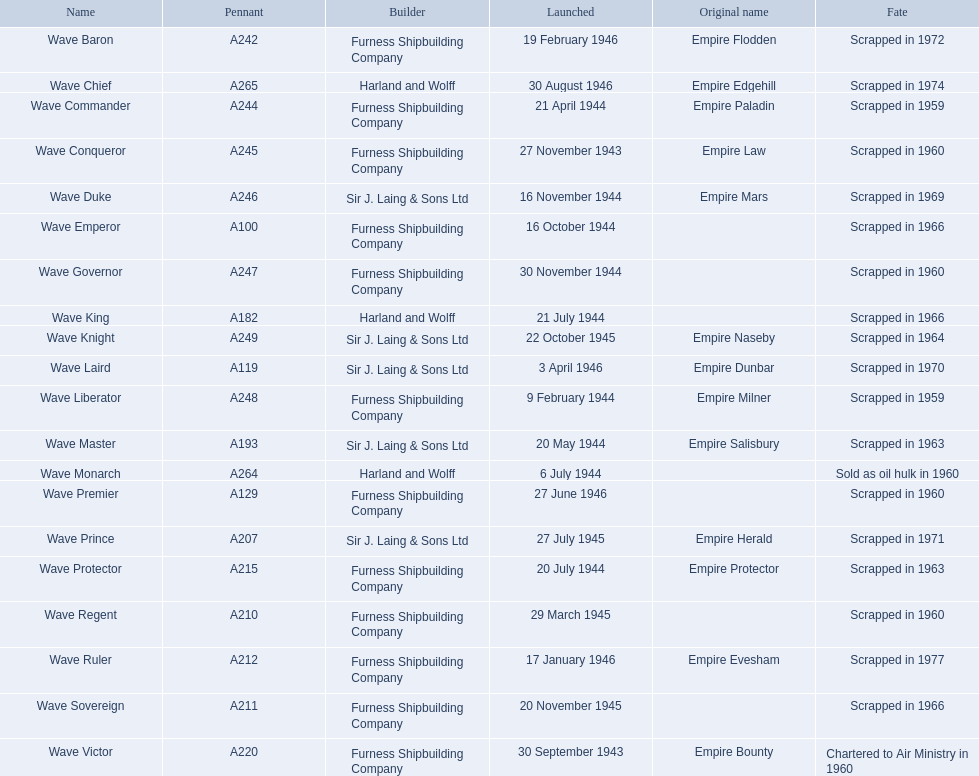What year was the wave victor launched? 30 September 1943. What other ship was launched in 1943? Wave Conqueror. Write the full table. {'header': ['Name', 'Pennant', 'Builder', 'Launched', 'Original name', 'Fate'], 'rows': [['Wave Baron', 'A242', 'Furness Shipbuilding Company', '19 February 1946', 'Empire Flodden', 'Scrapped in 1972'], ['Wave Chief', 'A265', 'Harland and Wolff', '30 August 1946', 'Empire Edgehill', 'Scrapped in 1974'], ['Wave Commander', 'A244', 'Furness Shipbuilding Company', '21 April 1944', 'Empire Paladin', 'Scrapped in 1959'], ['Wave Conqueror', 'A245', 'Furness Shipbuilding Company', '27 November 1943', 'Empire Law', 'Scrapped in 1960'], ['Wave Duke', 'A246', 'Sir J. Laing & Sons Ltd', '16 November 1944', 'Empire Mars', 'Scrapped in 1969'], ['Wave Emperor', 'A100', 'Furness Shipbuilding Company', '16 October 1944', '', 'Scrapped in 1966'], ['Wave Governor', 'A247', 'Furness Shipbuilding Company', '30 November 1944', '', 'Scrapped in 1960'], ['Wave King', 'A182', 'Harland and Wolff', '21 July 1944', '', 'Scrapped in 1966'], ['Wave Knight', 'A249', 'Sir J. Laing & Sons Ltd', '22 October 1945', 'Empire Naseby', 'Scrapped in 1964'], ['Wave Laird', 'A119', 'Sir J. Laing & Sons Ltd', '3 April 1946', 'Empire Dunbar', 'Scrapped in 1970'], ['Wave Liberator', 'A248', 'Furness Shipbuilding Company', '9 February 1944', 'Empire Milner', 'Scrapped in 1959'], ['Wave Master', 'A193', 'Sir J. Laing & Sons Ltd', '20 May 1944', 'Empire Salisbury', 'Scrapped in 1963'], ['Wave Monarch', 'A264', 'Harland and Wolff', '6 July 1944', '', 'Sold as oil hulk in 1960'], ['Wave Premier', 'A129', 'Furness Shipbuilding Company', '27 June 1946', '', 'Scrapped in 1960'], ['Wave Prince', 'A207', 'Sir J. Laing & Sons Ltd', '27 July 1945', 'Empire Herald', 'Scrapped in 1971'], ['Wave Protector', 'A215', 'Furness Shipbuilding Company', '20 July 1944', 'Empire Protector', 'Scrapped in 1963'], ['Wave Regent', 'A210', 'Furness Shipbuilding Company', '29 March 1945', '', 'Scrapped in 1960'], ['Wave Ruler', 'A212', 'Furness Shipbuilding Company', '17 January 1946', 'Empire Evesham', 'Scrapped in 1977'], ['Wave Sovereign', 'A211', 'Furness Shipbuilding Company', '20 November 1945', '', 'Scrapped in 1966'], ['Wave Victor', 'A220', 'Furness Shipbuilding Company', '30 September 1943', 'Empire Bounty', 'Chartered to Air Ministry in 1960']]} 